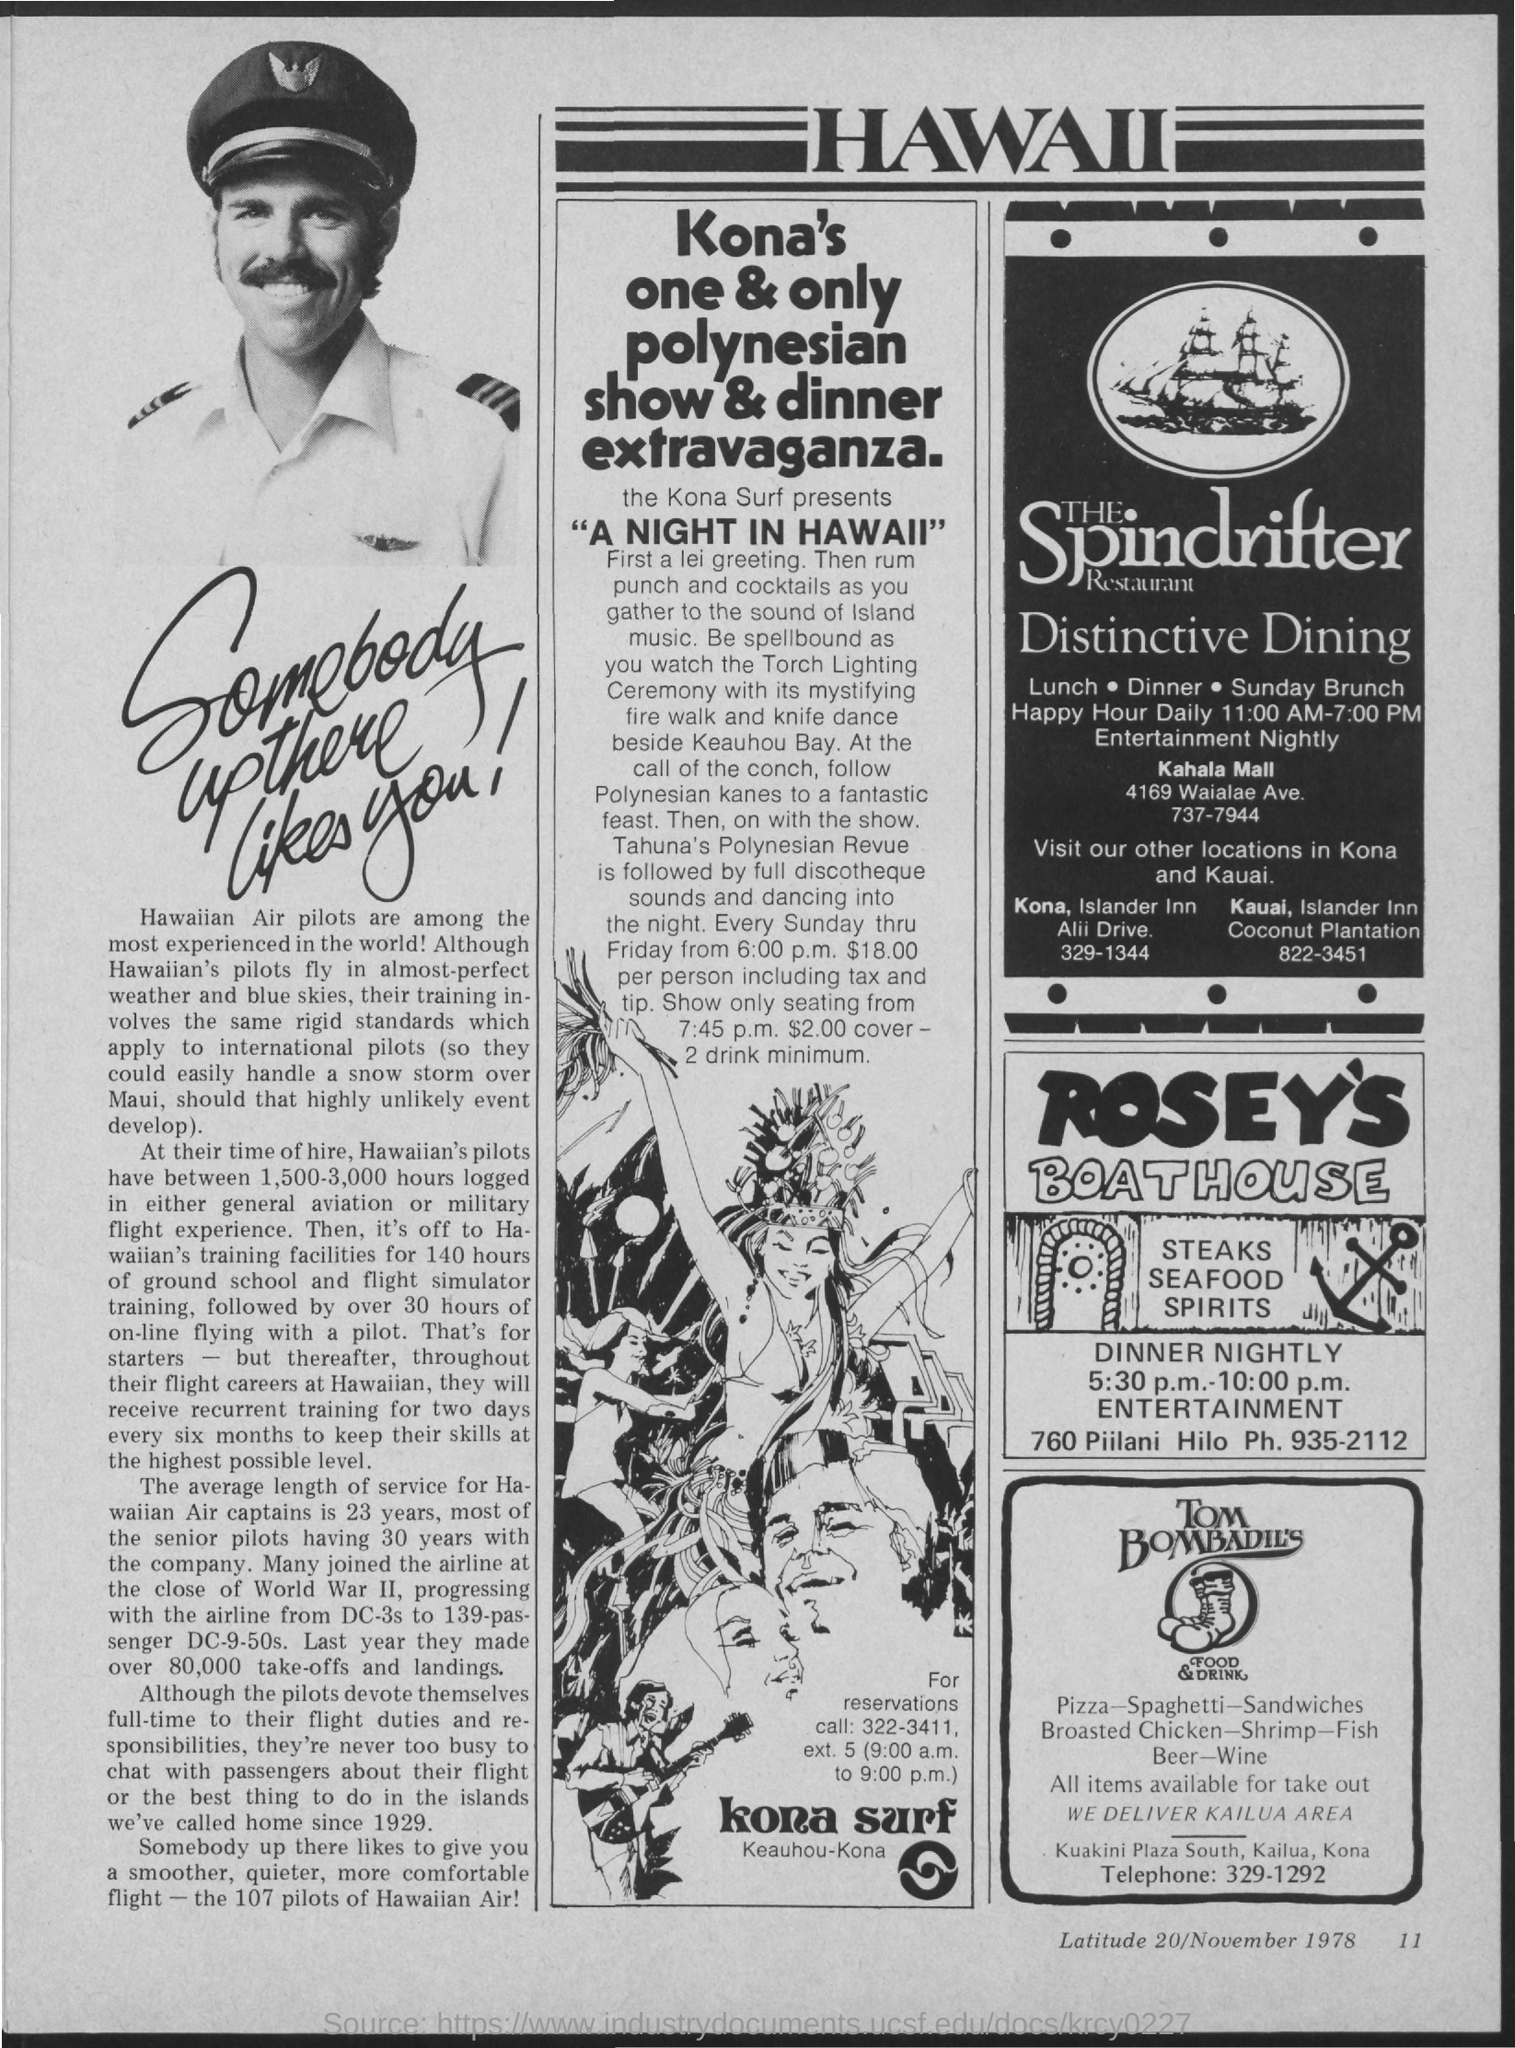Indicate a few pertinent items in this graphic. The Spindrifter Restaurant's tagline is 'Distinctive Dining,' which emphasizes the unique and exceptional dining experience that the restaurant provides to its patrons. The heading on the top of the page is 'Hawaii'. The page number at the bottom of the page is 11. The phone number of Rosey's Boathouse is 935-2112. Tom Bombadil's Food & Drink can be contacted by phone at 329-1292. 